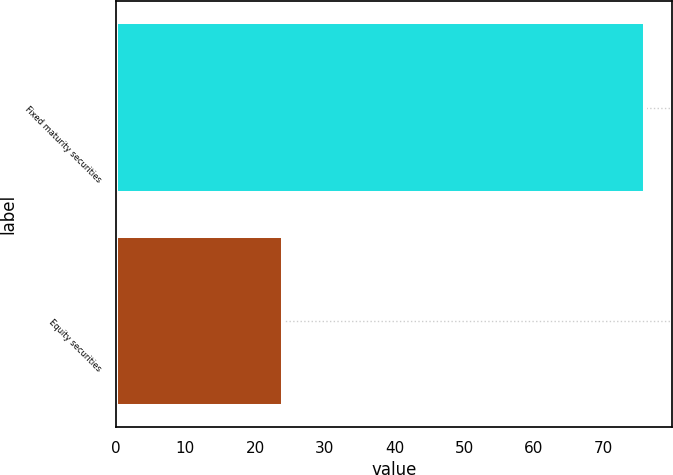<chart> <loc_0><loc_0><loc_500><loc_500><bar_chart><fcel>Fixed maturity securities<fcel>Equity securities<nl><fcel>76<fcel>24<nl></chart> 